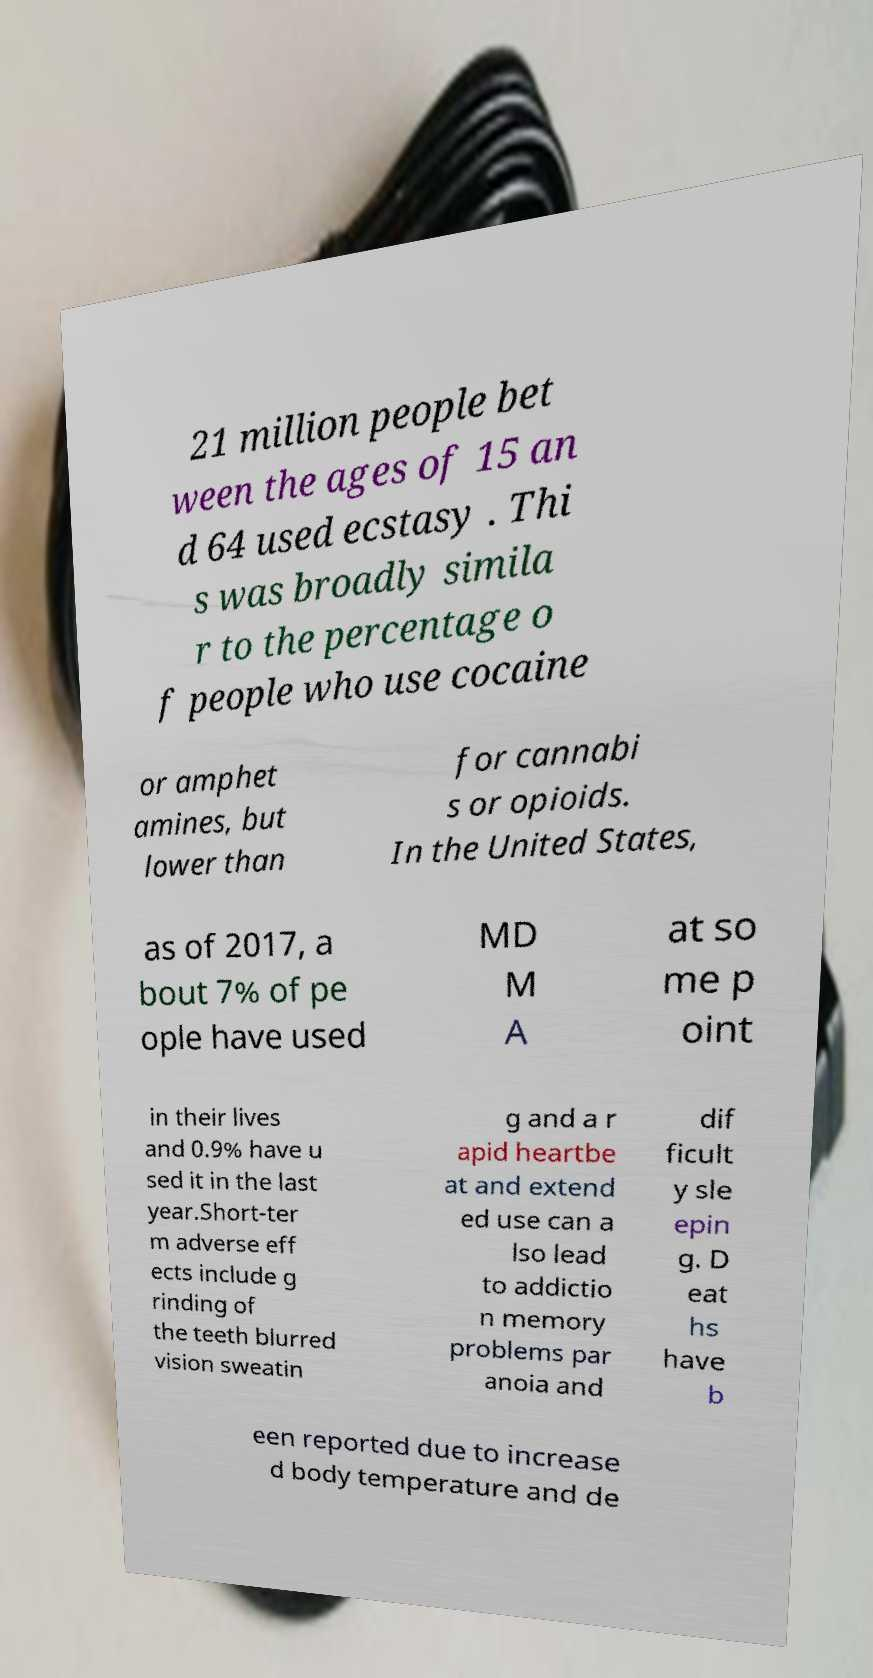Could you extract and type out the text from this image? 21 million people bet ween the ages of 15 an d 64 used ecstasy . Thi s was broadly simila r to the percentage o f people who use cocaine or amphet amines, but lower than for cannabi s or opioids. In the United States, as of 2017, a bout 7% of pe ople have used MD M A at so me p oint in their lives and 0.9% have u sed it in the last year.Short-ter m adverse eff ects include g rinding of the teeth blurred vision sweatin g and a r apid heartbe at and extend ed use can a lso lead to addictio n memory problems par anoia and dif ficult y sle epin g. D eat hs have b een reported due to increase d body temperature and de 